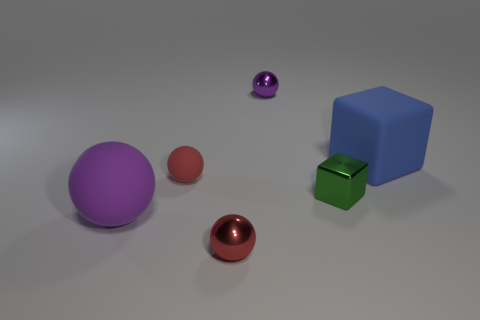Subtract 1 spheres. How many spheres are left? 3 Subtract all green spheres. Subtract all purple cylinders. How many spheres are left? 4 Add 2 small purple balls. How many objects exist? 8 Subtract all spheres. How many objects are left? 2 Subtract all large red metallic balls. Subtract all small red metallic things. How many objects are left? 5 Add 6 small green things. How many small green things are left? 7 Add 2 tiny blue metal objects. How many tiny blue metal objects exist? 2 Subtract 2 purple spheres. How many objects are left? 4 